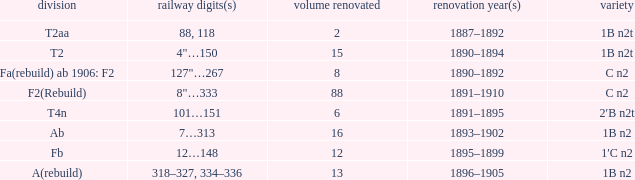What is the type if quantity rebuilt is more than 2 and the railway number is 4"…150? 1B n2t. 